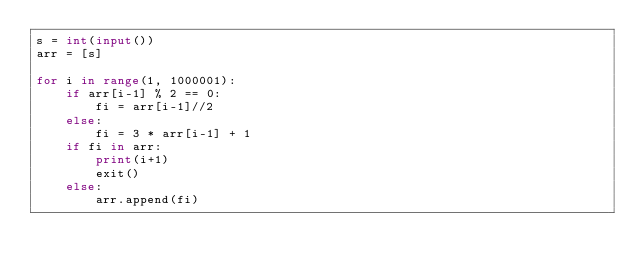<code> <loc_0><loc_0><loc_500><loc_500><_Python_>s = int(input())
arr = [s]

for i in range(1, 1000001):
    if arr[i-1] % 2 == 0:
        fi = arr[i-1]//2
    else:
        fi = 3 * arr[i-1] + 1
    if fi in arr:
        print(i+1)
        exit()
    else:
        arr.append(fi)</code> 